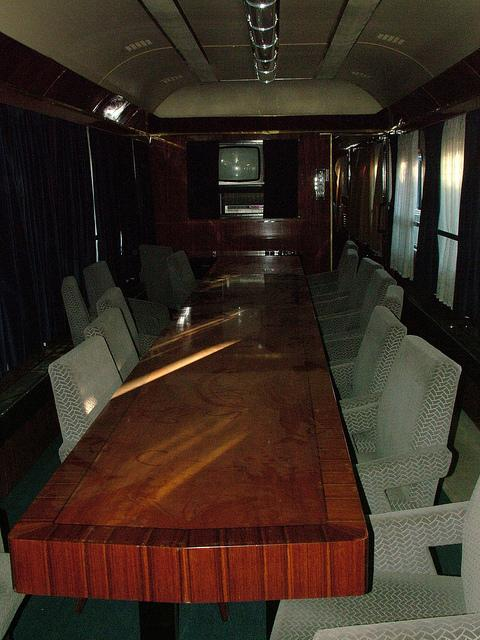The room here might be found where? Please explain your reasoning. train. This long room could be found on a train. 